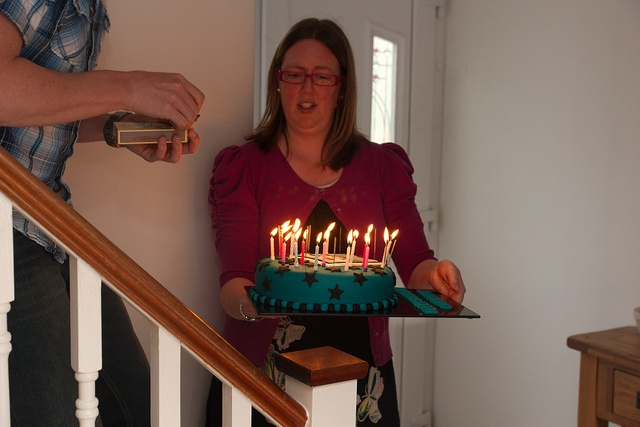Describe the objects in this image and their specific colors. I can see people in black, maroon, brown, and gray tones, people in black, brown, maroon, and gray tones, and cake in black, teal, maroon, and tan tones in this image. 